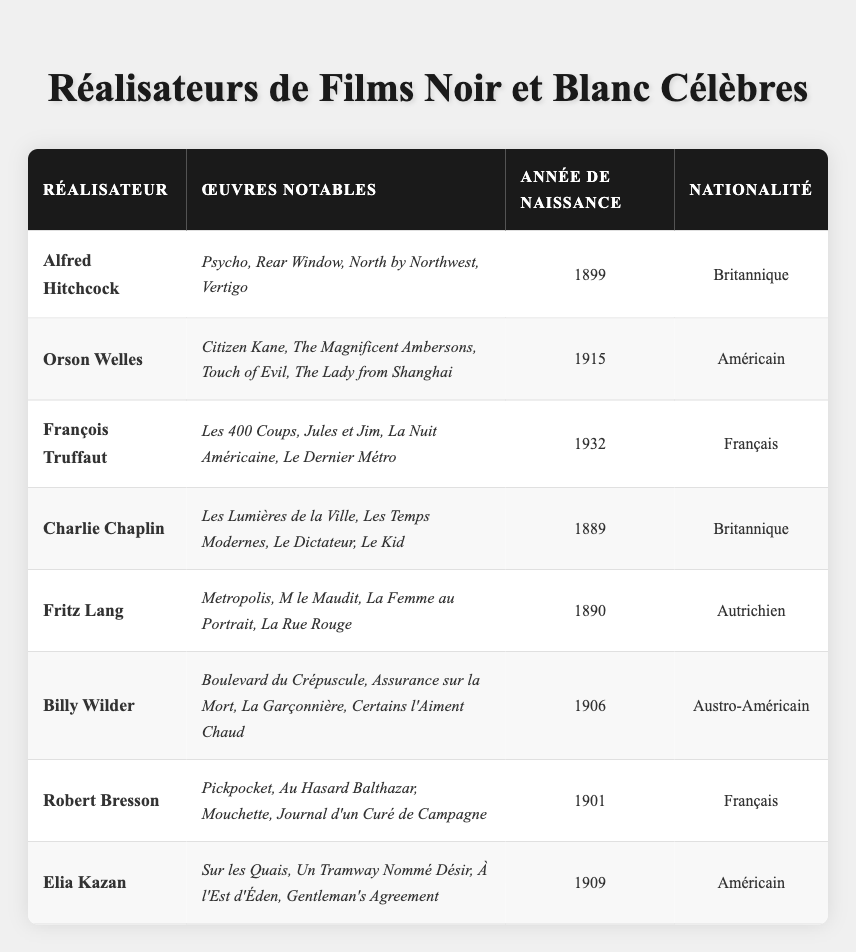Quel est le réalisateur né en 1889 ? Dans le tableau, on repère le réalisateur et sa date de naissance. Le réalisateur né en 1889 mentionné est Charlie Chaplin.
Answer: Charlie Chaplin Quels sont les films notables réalisés par François Truffaut ? On consulte la colonne « Œuvres Notables » pour François Truffaut. Les films énumérés sont : Les 400 Coups, Jules et Jim, La Nuit Américaine, Le Dernier Métro.
Answer: Les 400 Coups, Jules et Jim, La Nuit Américaine, Le Dernier Métro Quel directeur a la nationalité autrichienne ? On cherche dans la colonne « Nationalité » et identifions le réalisateur qui a cette nationalité. Il s'avère que Fritz Lang et Billy Wilder ont la nationalité autrichienne.
Answer: Fritz Lang, Billy Wilder Quel est le réalisateur le plus âgé dans la liste ? On compare les années de naissance des réalisateurs. Alfred Hitchcock est né en 1899, ce qui en fait le plus âgé de tous ceux listés.
Answer: Alfred Hitchcock Combien de réalisateurs sont nés après 1900 ? On examine les années de naissance des réalisateurs et comptons ceux nés après 1900. Les réalisateurs concernés sont Orson Welles (1915), François Truffaut (1932), et Elia Kazan (1909), soit trois réalisateurs au total.
Answer: 3 Vérifiez : est-ce vrai que Fritz Lang a réalisé « Metropolis » ? On examine la colonne « Œuvres Notables » pour Fritz Lang, qui mentionne bien « Metropolis », donc c'est vrai.
Answer: Oui Qui a réalisé "Citizen Kane" ? La colonne « Œuvres Notables » pour Orson Welles indique qu'il a réalisé « Citizen Kane ».
Answer: Orson Welles Quel est l'âge d'Alfred Hitchcock et de Charlie Chaplin combiné ? Alfred Hitchcock est né en 1899 et a 124 ans aujourd'hui. Charlie Chaplin, né en 1889, a 134 ans. En faisant l'addition : 124 + 134 = 258.
Answer: 258 Quelle est la nationalité de Robert Bresson ? En consultant la colonne « Nationalité », Robert Bresson est identifié comme français.
Answer: Français Quel réalisateur a le plus de films notables listés ? En examinant les colonnes correspondantes, chaque réalisateur a quatre films notables listés, donc ils sont tous au même niveau à cet égard.
Answer: Tous ont 4 films 